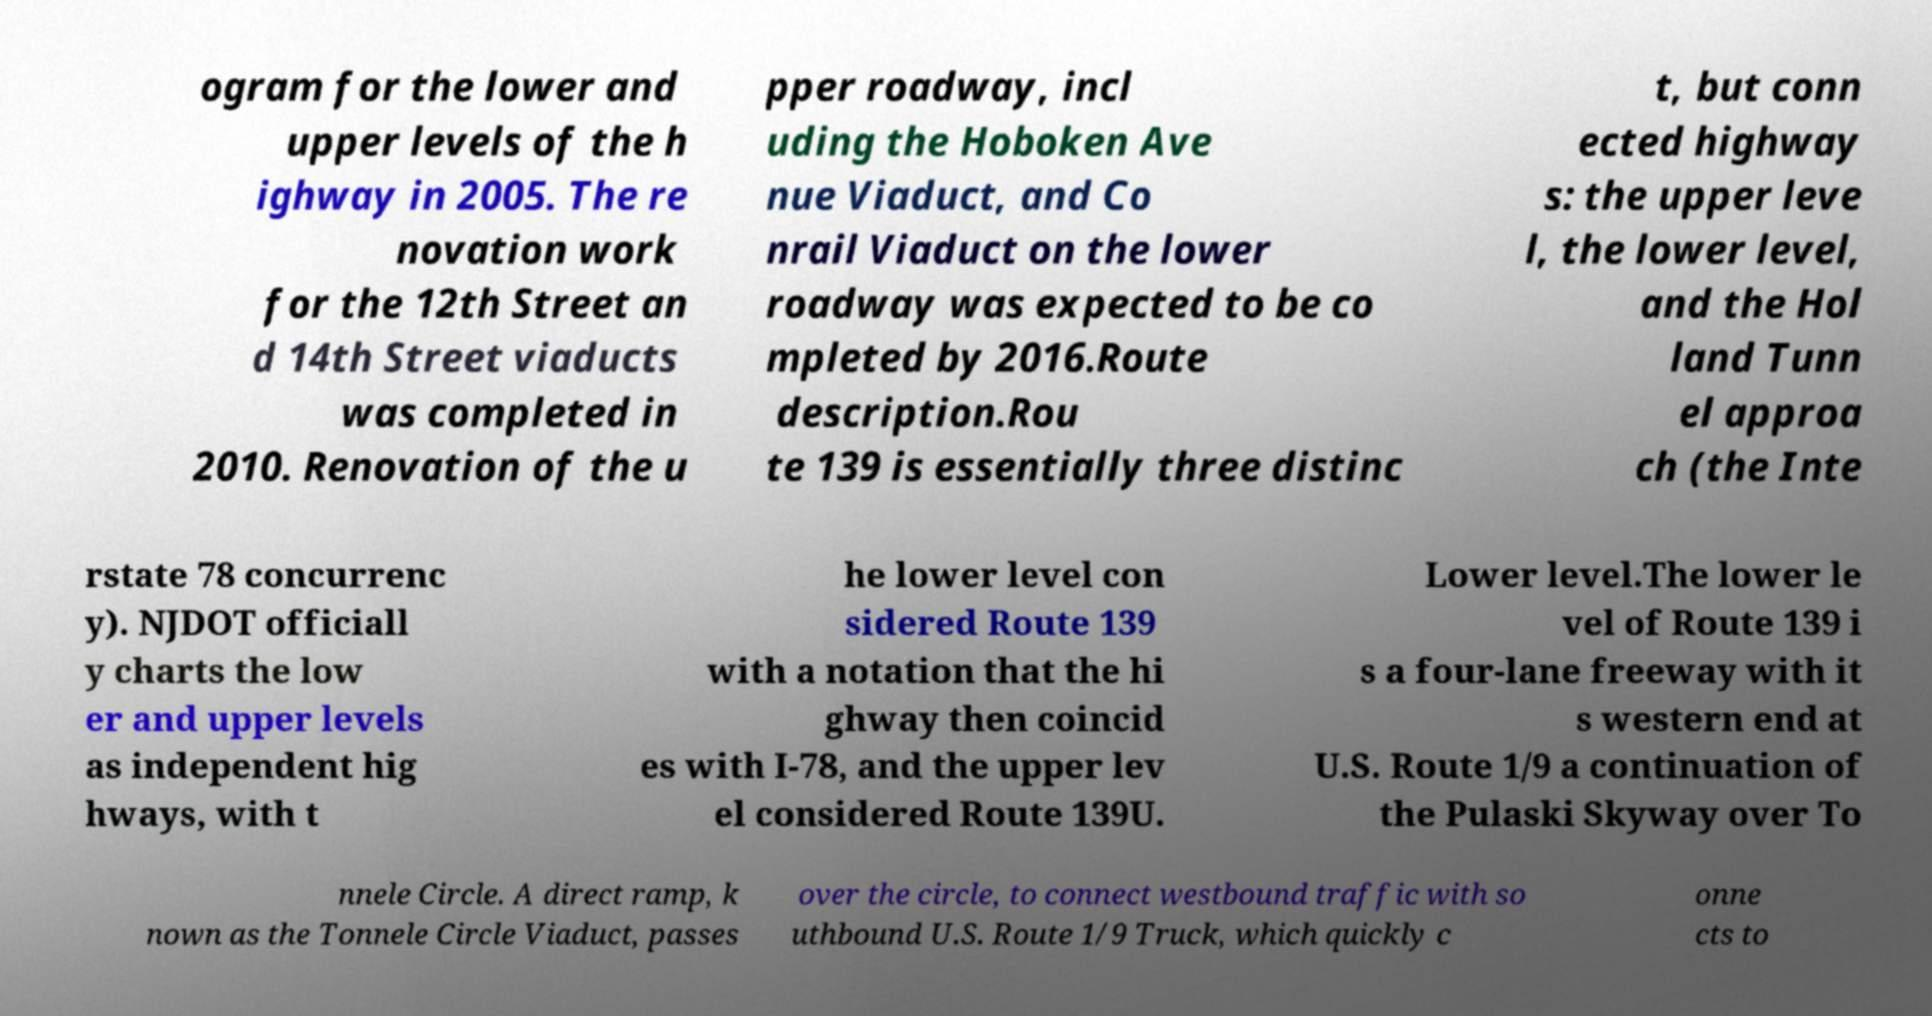I need the written content from this picture converted into text. Can you do that? ogram for the lower and upper levels of the h ighway in 2005. The re novation work for the 12th Street an d 14th Street viaducts was completed in 2010. Renovation of the u pper roadway, incl uding the Hoboken Ave nue Viaduct, and Co nrail Viaduct on the lower roadway was expected to be co mpleted by 2016.Route description.Rou te 139 is essentially three distinc t, but conn ected highway s: the upper leve l, the lower level, and the Hol land Tunn el approa ch (the Inte rstate 78 concurrenc y). NJDOT officiall y charts the low er and upper levels as independent hig hways, with t he lower level con sidered Route 139 with a notation that the hi ghway then coincid es with I-78, and the upper lev el considered Route 139U. Lower level.The lower le vel of Route 139 i s a four-lane freeway with it s western end at U.S. Route 1/9 a continuation of the Pulaski Skyway over To nnele Circle. A direct ramp, k nown as the Tonnele Circle Viaduct, passes over the circle, to connect westbound traffic with so uthbound U.S. Route 1/9 Truck, which quickly c onne cts to 